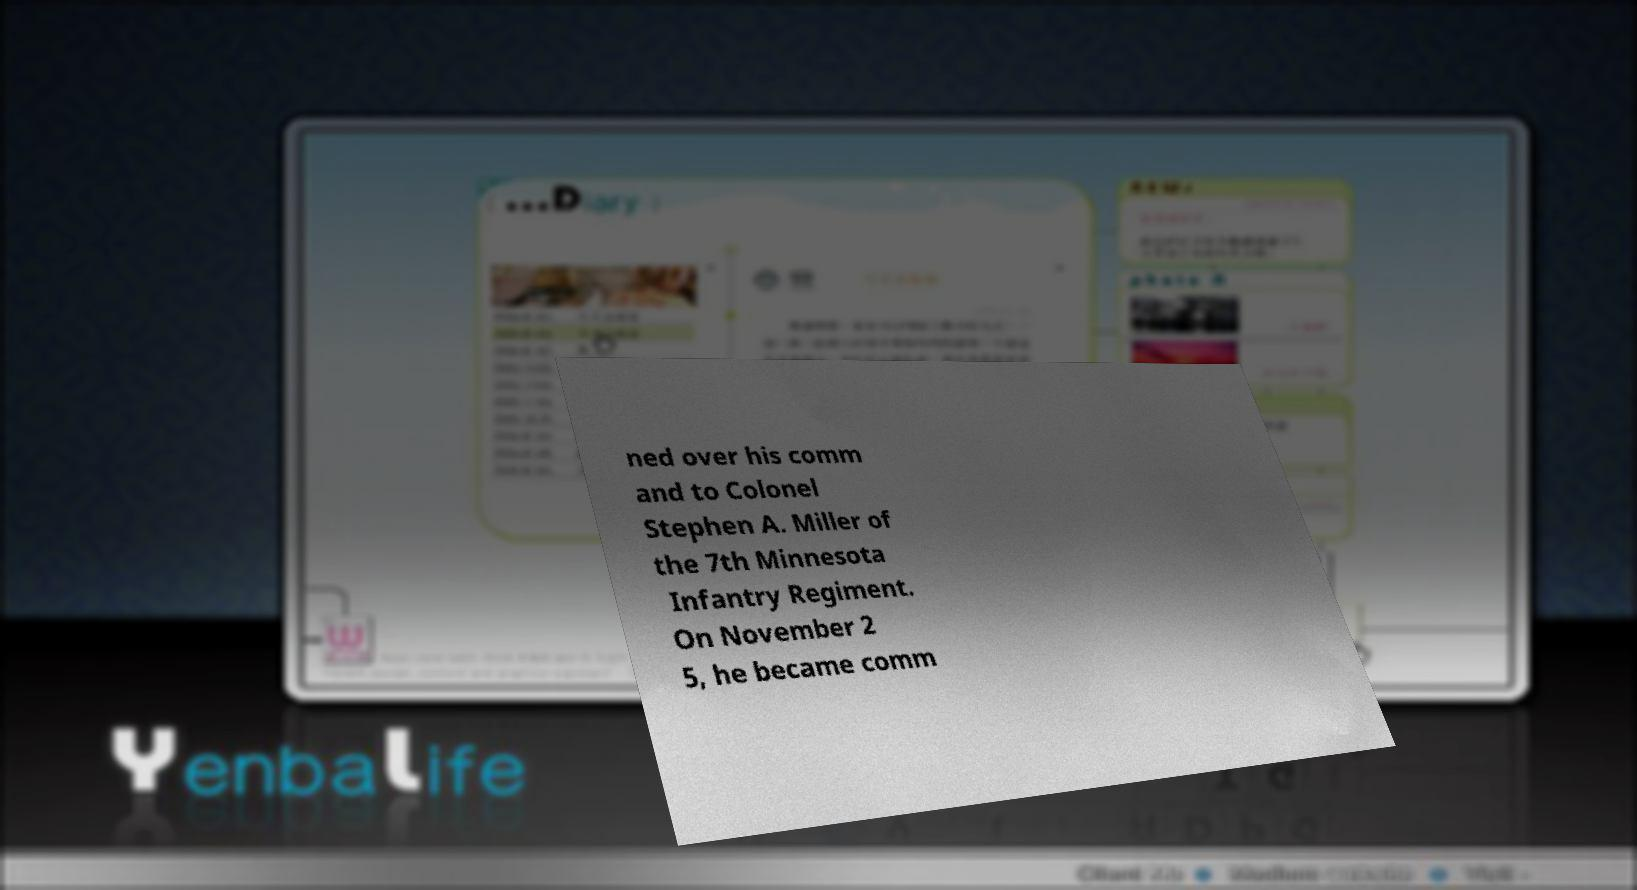Could you extract and type out the text from this image? ned over his comm and to Colonel Stephen A. Miller of the 7th Minnesota Infantry Regiment. On November 2 5, he became comm 